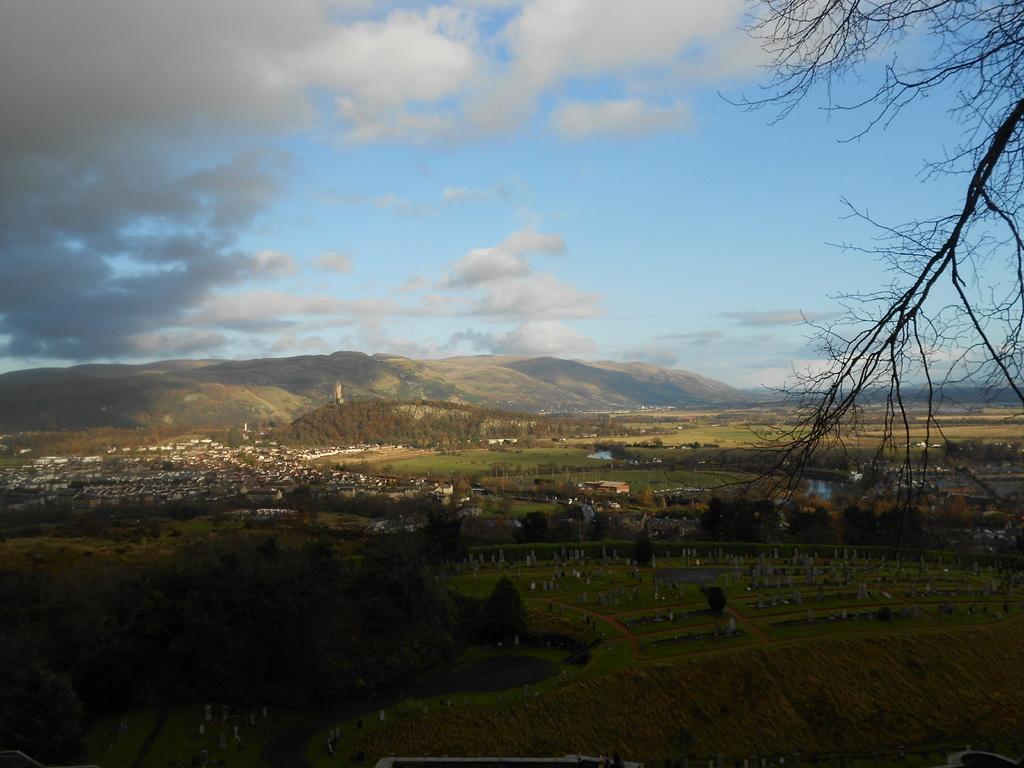Describe this image in one or two sentences. At the bottom of the image there is grass and trees and buildings and hills. At the top of the image there are some clouds and sky. 